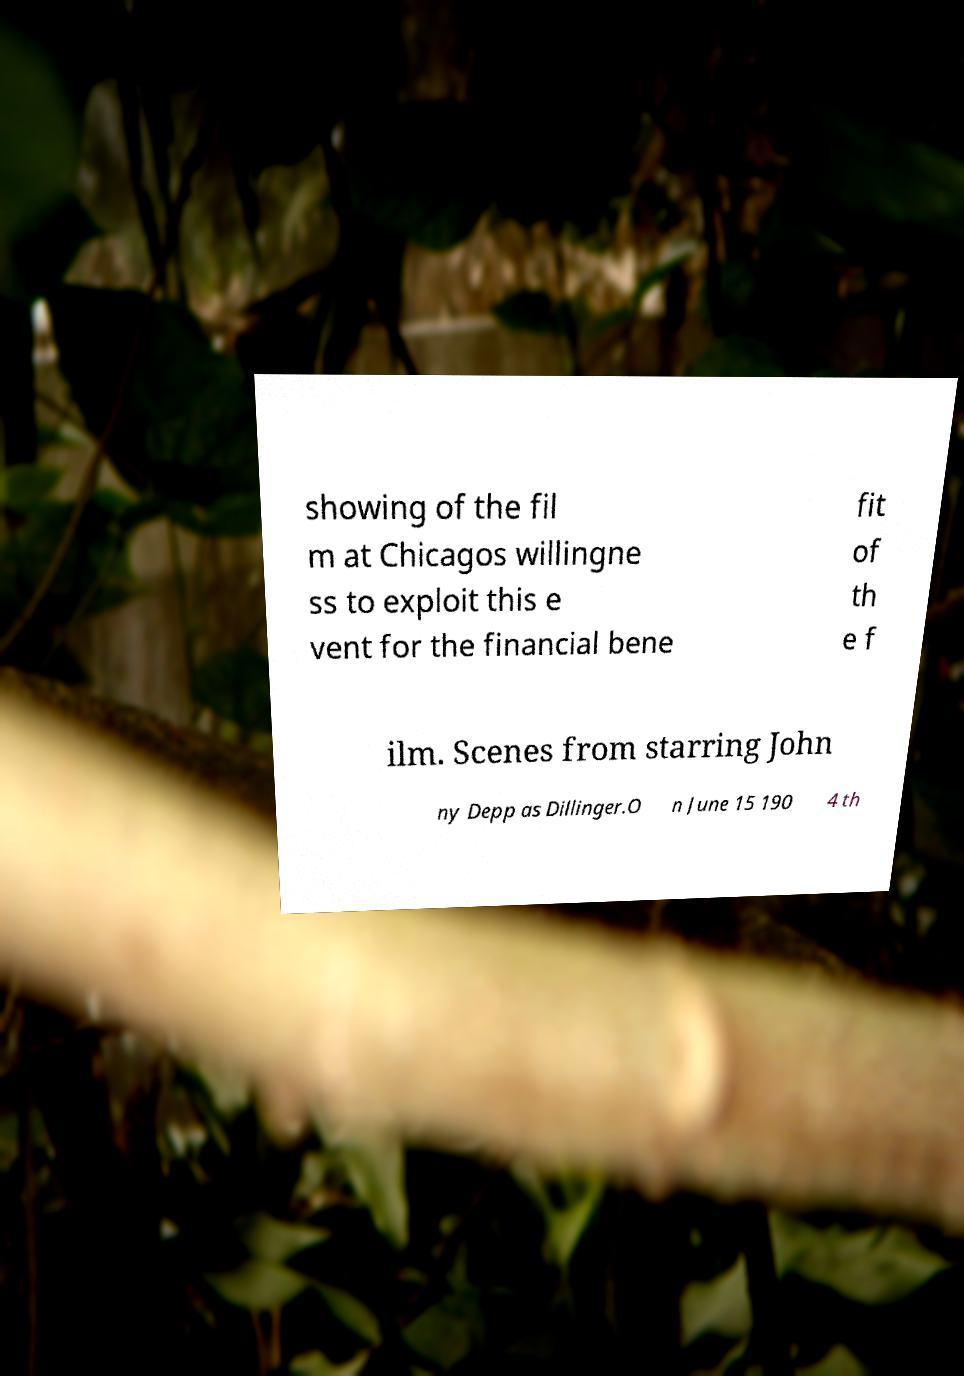Can you accurately transcribe the text from the provided image for me? showing of the fil m at Chicagos willingne ss to exploit this e vent for the financial bene fit of th e f ilm. Scenes from starring John ny Depp as Dillinger.O n June 15 190 4 th 